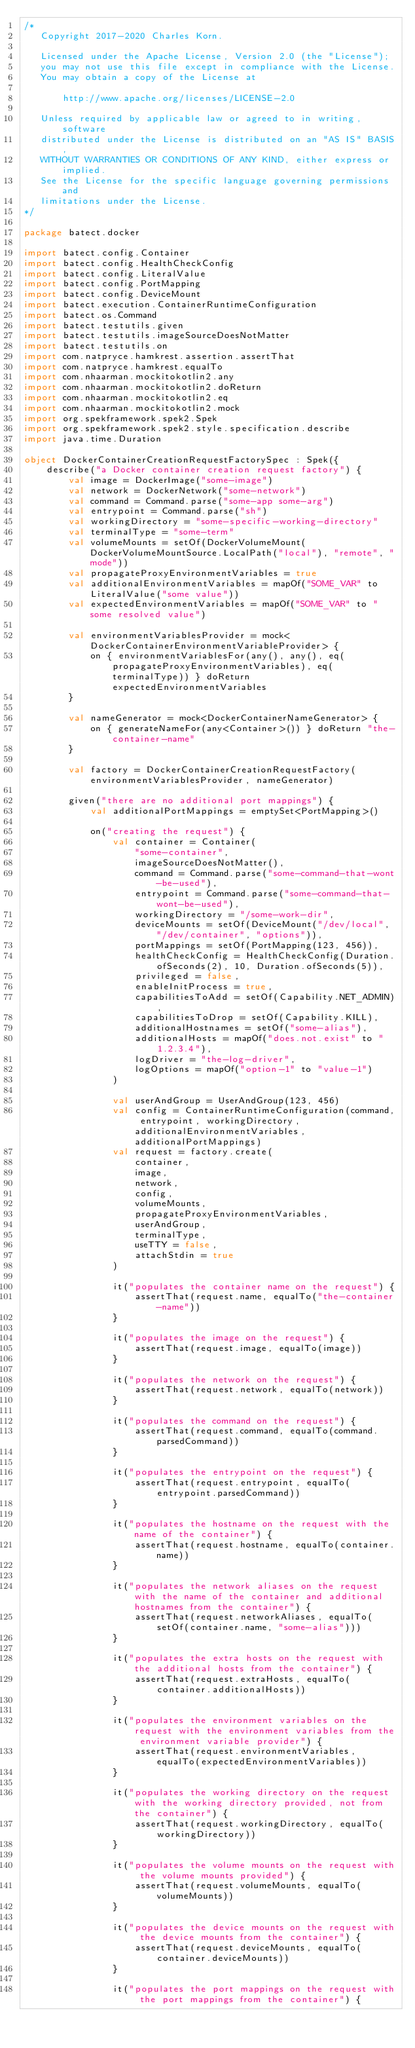Convert code to text. <code><loc_0><loc_0><loc_500><loc_500><_Kotlin_>/*
   Copyright 2017-2020 Charles Korn.

   Licensed under the Apache License, Version 2.0 (the "License");
   you may not use this file except in compliance with the License.
   You may obtain a copy of the License at

       http://www.apache.org/licenses/LICENSE-2.0

   Unless required by applicable law or agreed to in writing, software
   distributed under the License is distributed on an "AS IS" BASIS,
   WITHOUT WARRANTIES OR CONDITIONS OF ANY KIND, either express or implied.
   See the License for the specific language governing permissions and
   limitations under the License.
*/

package batect.docker

import batect.config.Container
import batect.config.HealthCheckConfig
import batect.config.LiteralValue
import batect.config.PortMapping
import batect.config.DeviceMount
import batect.execution.ContainerRuntimeConfiguration
import batect.os.Command
import batect.testutils.given
import batect.testutils.imageSourceDoesNotMatter
import batect.testutils.on
import com.natpryce.hamkrest.assertion.assertThat
import com.natpryce.hamkrest.equalTo
import com.nhaarman.mockitokotlin2.any
import com.nhaarman.mockitokotlin2.doReturn
import com.nhaarman.mockitokotlin2.eq
import com.nhaarman.mockitokotlin2.mock
import org.spekframework.spek2.Spek
import org.spekframework.spek2.style.specification.describe
import java.time.Duration

object DockerContainerCreationRequestFactorySpec : Spek({
    describe("a Docker container creation request factory") {
        val image = DockerImage("some-image")
        val network = DockerNetwork("some-network")
        val command = Command.parse("some-app some-arg")
        val entrypoint = Command.parse("sh")
        val workingDirectory = "some-specific-working-directory"
        val terminalType = "some-term"
        val volumeMounts = setOf(DockerVolumeMount(DockerVolumeMountSource.LocalPath("local"), "remote", "mode"))
        val propagateProxyEnvironmentVariables = true
        val additionalEnvironmentVariables = mapOf("SOME_VAR" to LiteralValue("some value"))
        val expectedEnvironmentVariables = mapOf("SOME_VAR" to "some resolved value")

        val environmentVariablesProvider = mock<DockerContainerEnvironmentVariableProvider> {
            on { environmentVariablesFor(any(), any(), eq(propagateProxyEnvironmentVariables), eq(terminalType)) } doReturn expectedEnvironmentVariables
        }

        val nameGenerator = mock<DockerContainerNameGenerator> {
            on { generateNameFor(any<Container>()) } doReturn "the-container-name"
        }

        val factory = DockerContainerCreationRequestFactory(environmentVariablesProvider, nameGenerator)

        given("there are no additional port mappings") {
            val additionalPortMappings = emptySet<PortMapping>()

            on("creating the request") {
                val container = Container(
                    "some-container",
                    imageSourceDoesNotMatter(),
                    command = Command.parse("some-command-that-wont-be-used"),
                    entrypoint = Command.parse("some-command-that-wont-be-used"),
                    workingDirectory = "/some-work-dir",
                    deviceMounts = setOf(DeviceMount("/dev/local", "/dev/container", "options")),
                    portMappings = setOf(PortMapping(123, 456)),
                    healthCheckConfig = HealthCheckConfig(Duration.ofSeconds(2), 10, Duration.ofSeconds(5)),
                    privileged = false,
                    enableInitProcess = true,
                    capabilitiesToAdd = setOf(Capability.NET_ADMIN),
                    capabilitiesToDrop = setOf(Capability.KILL),
                    additionalHostnames = setOf("some-alias"),
                    additionalHosts = mapOf("does.not.exist" to "1.2.3.4"),
                    logDriver = "the-log-driver",
                    logOptions = mapOf("option-1" to "value-1")
                )

                val userAndGroup = UserAndGroup(123, 456)
                val config = ContainerRuntimeConfiguration(command, entrypoint, workingDirectory, additionalEnvironmentVariables, additionalPortMappings)
                val request = factory.create(
                    container,
                    image,
                    network,
                    config,
                    volumeMounts,
                    propagateProxyEnvironmentVariables,
                    userAndGroup,
                    terminalType,
                    useTTY = false,
                    attachStdin = true
                )

                it("populates the container name on the request") {
                    assertThat(request.name, equalTo("the-container-name"))
                }

                it("populates the image on the request") {
                    assertThat(request.image, equalTo(image))
                }

                it("populates the network on the request") {
                    assertThat(request.network, equalTo(network))
                }

                it("populates the command on the request") {
                    assertThat(request.command, equalTo(command.parsedCommand))
                }

                it("populates the entrypoint on the request") {
                    assertThat(request.entrypoint, equalTo(entrypoint.parsedCommand))
                }

                it("populates the hostname on the request with the name of the container") {
                    assertThat(request.hostname, equalTo(container.name))
                }

                it("populates the network aliases on the request with the name of the container and additional hostnames from the container") {
                    assertThat(request.networkAliases, equalTo(setOf(container.name, "some-alias")))
                }

                it("populates the extra hosts on the request with the additional hosts from the container") {
                    assertThat(request.extraHosts, equalTo(container.additionalHosts))
                }

                it("populates the environment variables on the request with the environment variables from the environment variable provider") {
                    assertThat(request.environmentVariables, equalTo(expectedEnvironmentVariables))
                }

                it("populates the working directory on the request with the working directory provided, not from the container") {
                    assertThat(request.workingDirectory, equalTo(workingDirectory))
                }

                it("populates the volume mounts on the request with the volume mounts provided") {
                    assertThat(request.volumeMounts, equalTo(volumeMounts))
                }

                it("populates the device mounts on the request with the device mounts from the container") {
                    assertThat(request.deviceMounts, equalTo(container.deviceMounts))
                }

                it("populates the port mappings on the request with the port mappings from the container") {</code> 